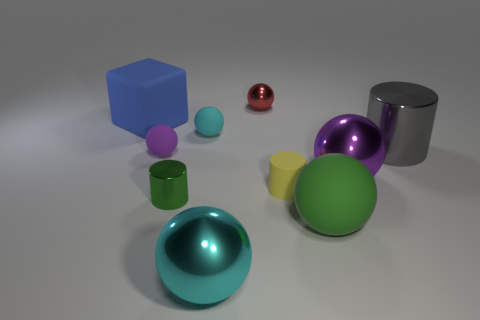How many purple balls must be subtracted to get 1 purple balls? 1 Subtract all green spheres. How many spheres are left? 5 Subtract all large green rubber balls. How many balls are left? 5 Subtract all red spheres. Subtract all brown cylinders. How many spheres are left? 5 Subtract all cylinders. How many objects are left? 7 Subtract all small purple rubber things. Subtract all red balls. How many objects are left? 8 Add 7 large cylinders. How many large cylinders are left? 8 Add 6 big purple balls. How many big purple balls exist? 7 Subtract 0 cyan cylinders. How many objects are left? 10 